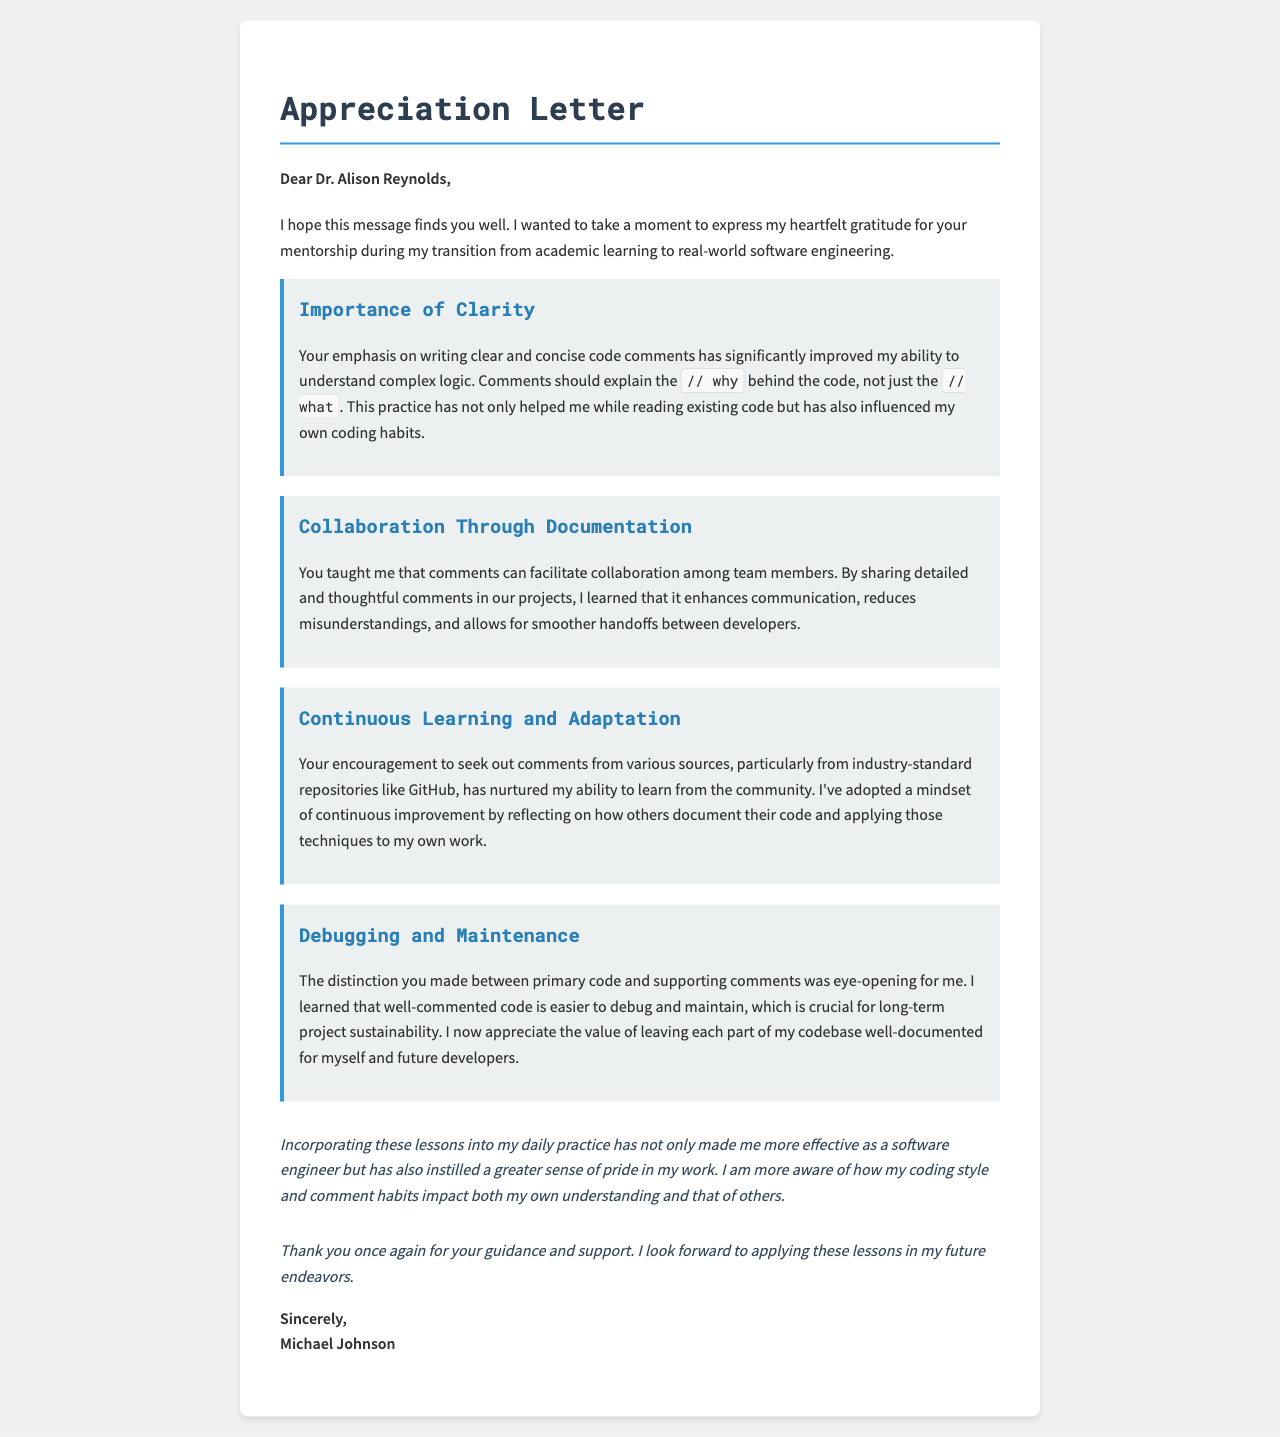What is the name of the mentor? The letter addresses Dr. Alison Reynolds, indicating that she is the mentor being appreciated.
Answer: Dr. Alison Reynolds Who is the author of the letter? The signature at the end of the letter reveals the author as Michael Johnson.
Answer: Michael Johnson How many key lessons are highlighted in the letter? The letter outlines four distinct lessons learned from code comments.
Answer: Four What lesson emphasizes the importance of writing clear comments? The lesson titled "Importance of Clarity" discusses writing clear and concise code comments.
Answer: Importance of Clarity What does the author learn about teamwork from comments? The lesson "Collaboration Through Documentation" explains that comments facilitate communication and collaboration.
Answer: Collaboration Through Documentation Which lesson encourages continuous improvement? The lesson "Continuous Learning and Adaptation" promotes a mindset of continuous learning through community resources.
Answer: Continuous Learning and Adaptation What is the primary focus of the lesson titled "Debugging and Maintenance"? This lesson emphasizes that well-commented code is easier to debug and maintain for long-term sustainability.
Answer: Well-commented code What effect has incorporating these lessons had on the author? The author mentions becoming more effective as a software engineer and having greater pride in their work.
Answer: More effective What style of letter is used in the document? The document is framed as an appreciation letter, which is a specific format for expressing gratitude.
Answer: Appreciation letter 